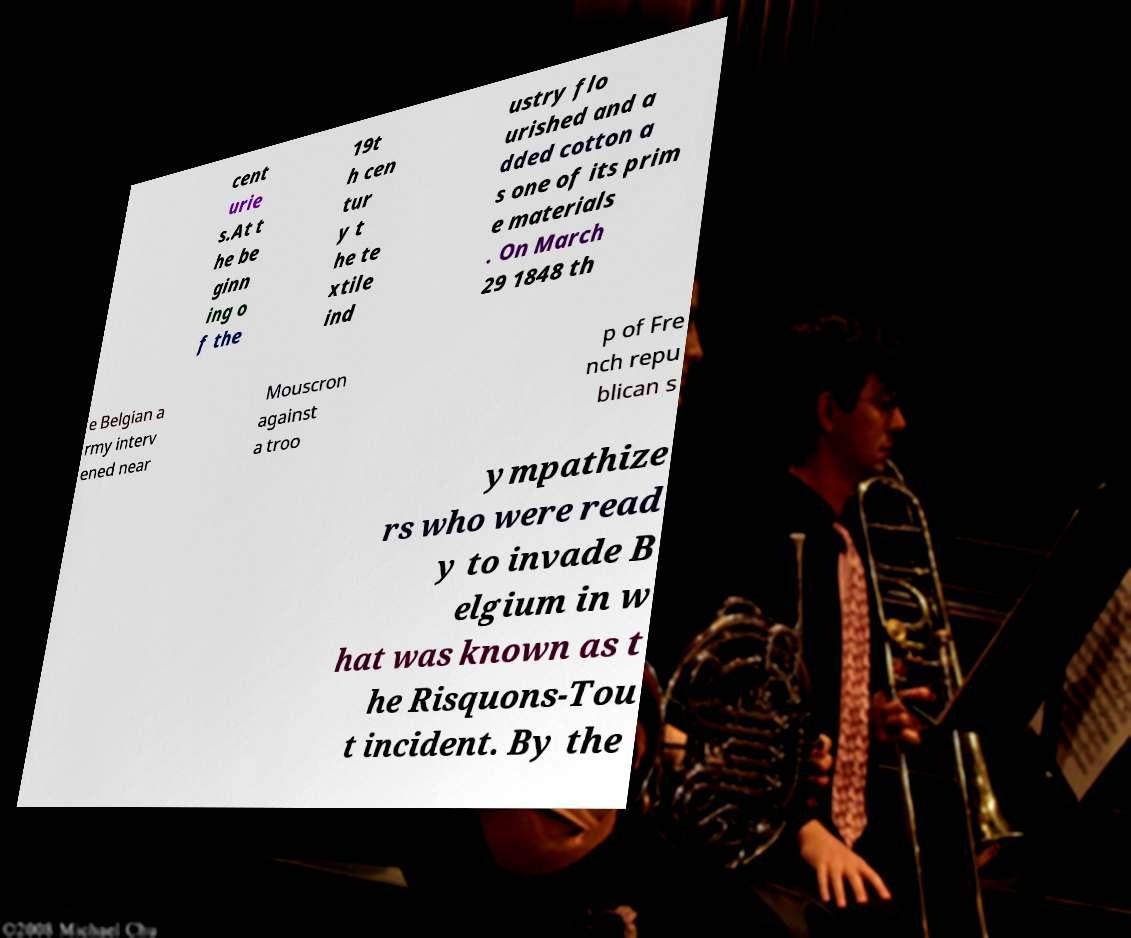Could you assist in decoding the text presented in this image and type it out clearly? cent urie s.At t he be ginn ing o f the 19t h cen tur y t he te xtile ind ustry flo urished and a dded cotton a s one of its prim e materials . On March 29 1848 th e Belgian a rmy interv ened near Mouscron against a troo p of Fre nch repu blican s ympathize rs who were read y to invade B elgium in w hat was known as t he Risquons-Tou t incident. By the 